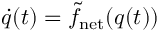<formula> <loc_0><loc_0><loc_500><loc_500>\begin{array} { r } { \dot { q } ( t ) = \tilde { f } _ { n e t } ( q ( t ) ) } \end{array}</formula> 